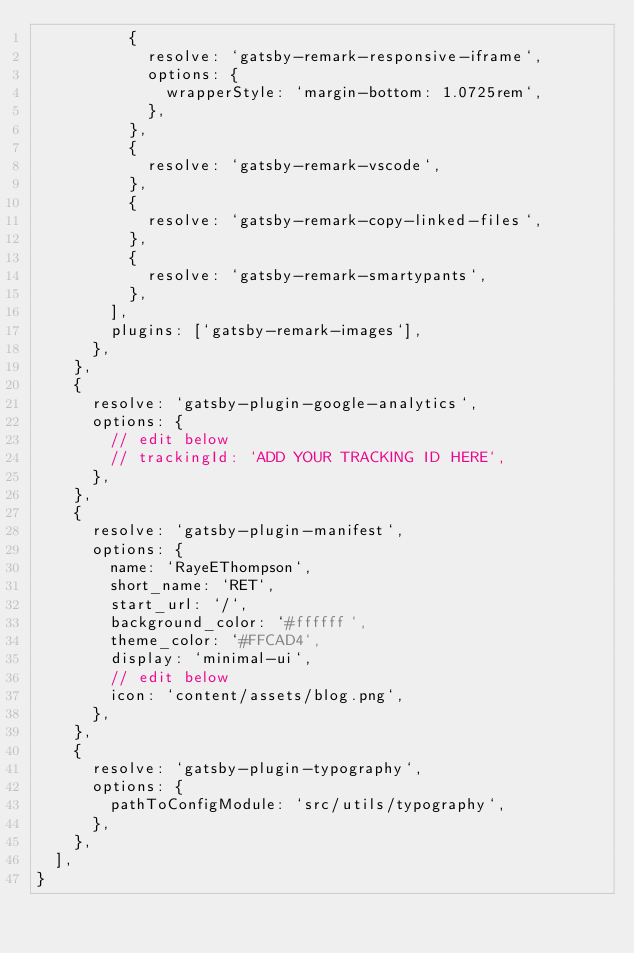Convert code to text. <code><loc_0><loc_0><loc_500><loc_500><_JavaScript_>          {
            resolve: `gatsby-remark-responsive-iframe`,
            options: {
              wrapperStyle: `margin-bottom: 1.0725rem`,
            },
          },
          {
            resolve: `gatsby-remark-vscode`,
          },
          {
            resolve: `gatsby-remark-copy-linked-files`,
          },
          {
            resolve: `gatsby-remark-smartypants`,
          },
        ],
        plugins: [`gatsby-remark-images`],
      },
    },
    {
      resolve: `gatsby-plugin-google-analytics`,
      options: {
        // edit below
        // trackingId: `ADD YOUR TRACKING ID HERE`,
      },
    },
    {
      resolve: `gatsby-plugin-manifest`,
      options: {
        name: `RayeEThompson`,
        short_name: `RET`,
        start_url: `/`,
        background_color: `#ffffff`,
        theme_color: `#FFCAD4`,
        display: `minimal-ui`,
        // edit below
        icon: `content/assets/blog.png`,
      },
    },
    {
      resolve: `gatsby-plugin-typography`,
      options: {
        pathToConfigModule: `src/utils/typography`,
      },
    },
  ],
}
</code> 